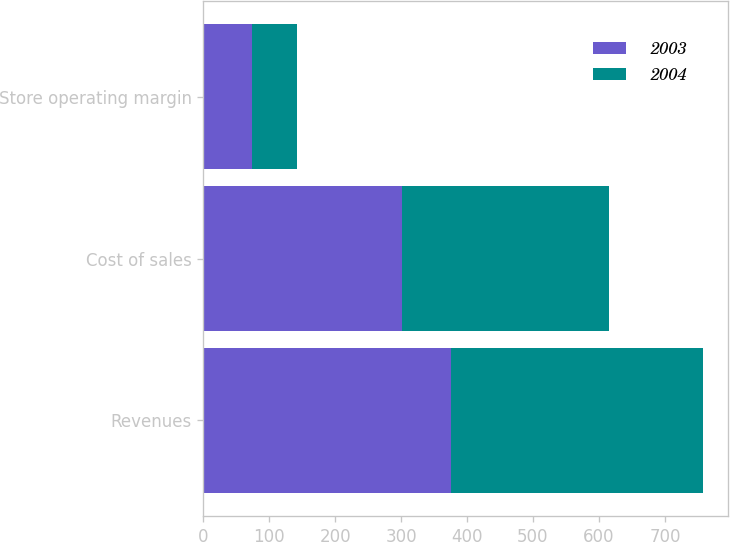Convert chart to OTSL. <chart><loc_0><loc_0><loc_500><loc_500><stacked_bar_chart><ecel><fcel>Revenues<fcel>Cost of sales<fcel>Store operating margin<nl><fcel>2003<fcel>375.4<fcel>302<fcel>73.4<nl><fcel>2004<fcel>382.5<fcel>313.6<fcel>68.9<nl></chart> 